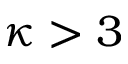<formula> <loc_0><loc_0><loc_500><loc_500>\kappa > 3</formula> 